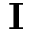Convert formula to latex. <formula><loc_0><loc_0><loc_500><loc_500>I</formula> 